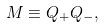<formula> <loc_0><loc_0><loc_500><loc_500>M \equiv Q _ { + } Q _ { - } ,</formula> 